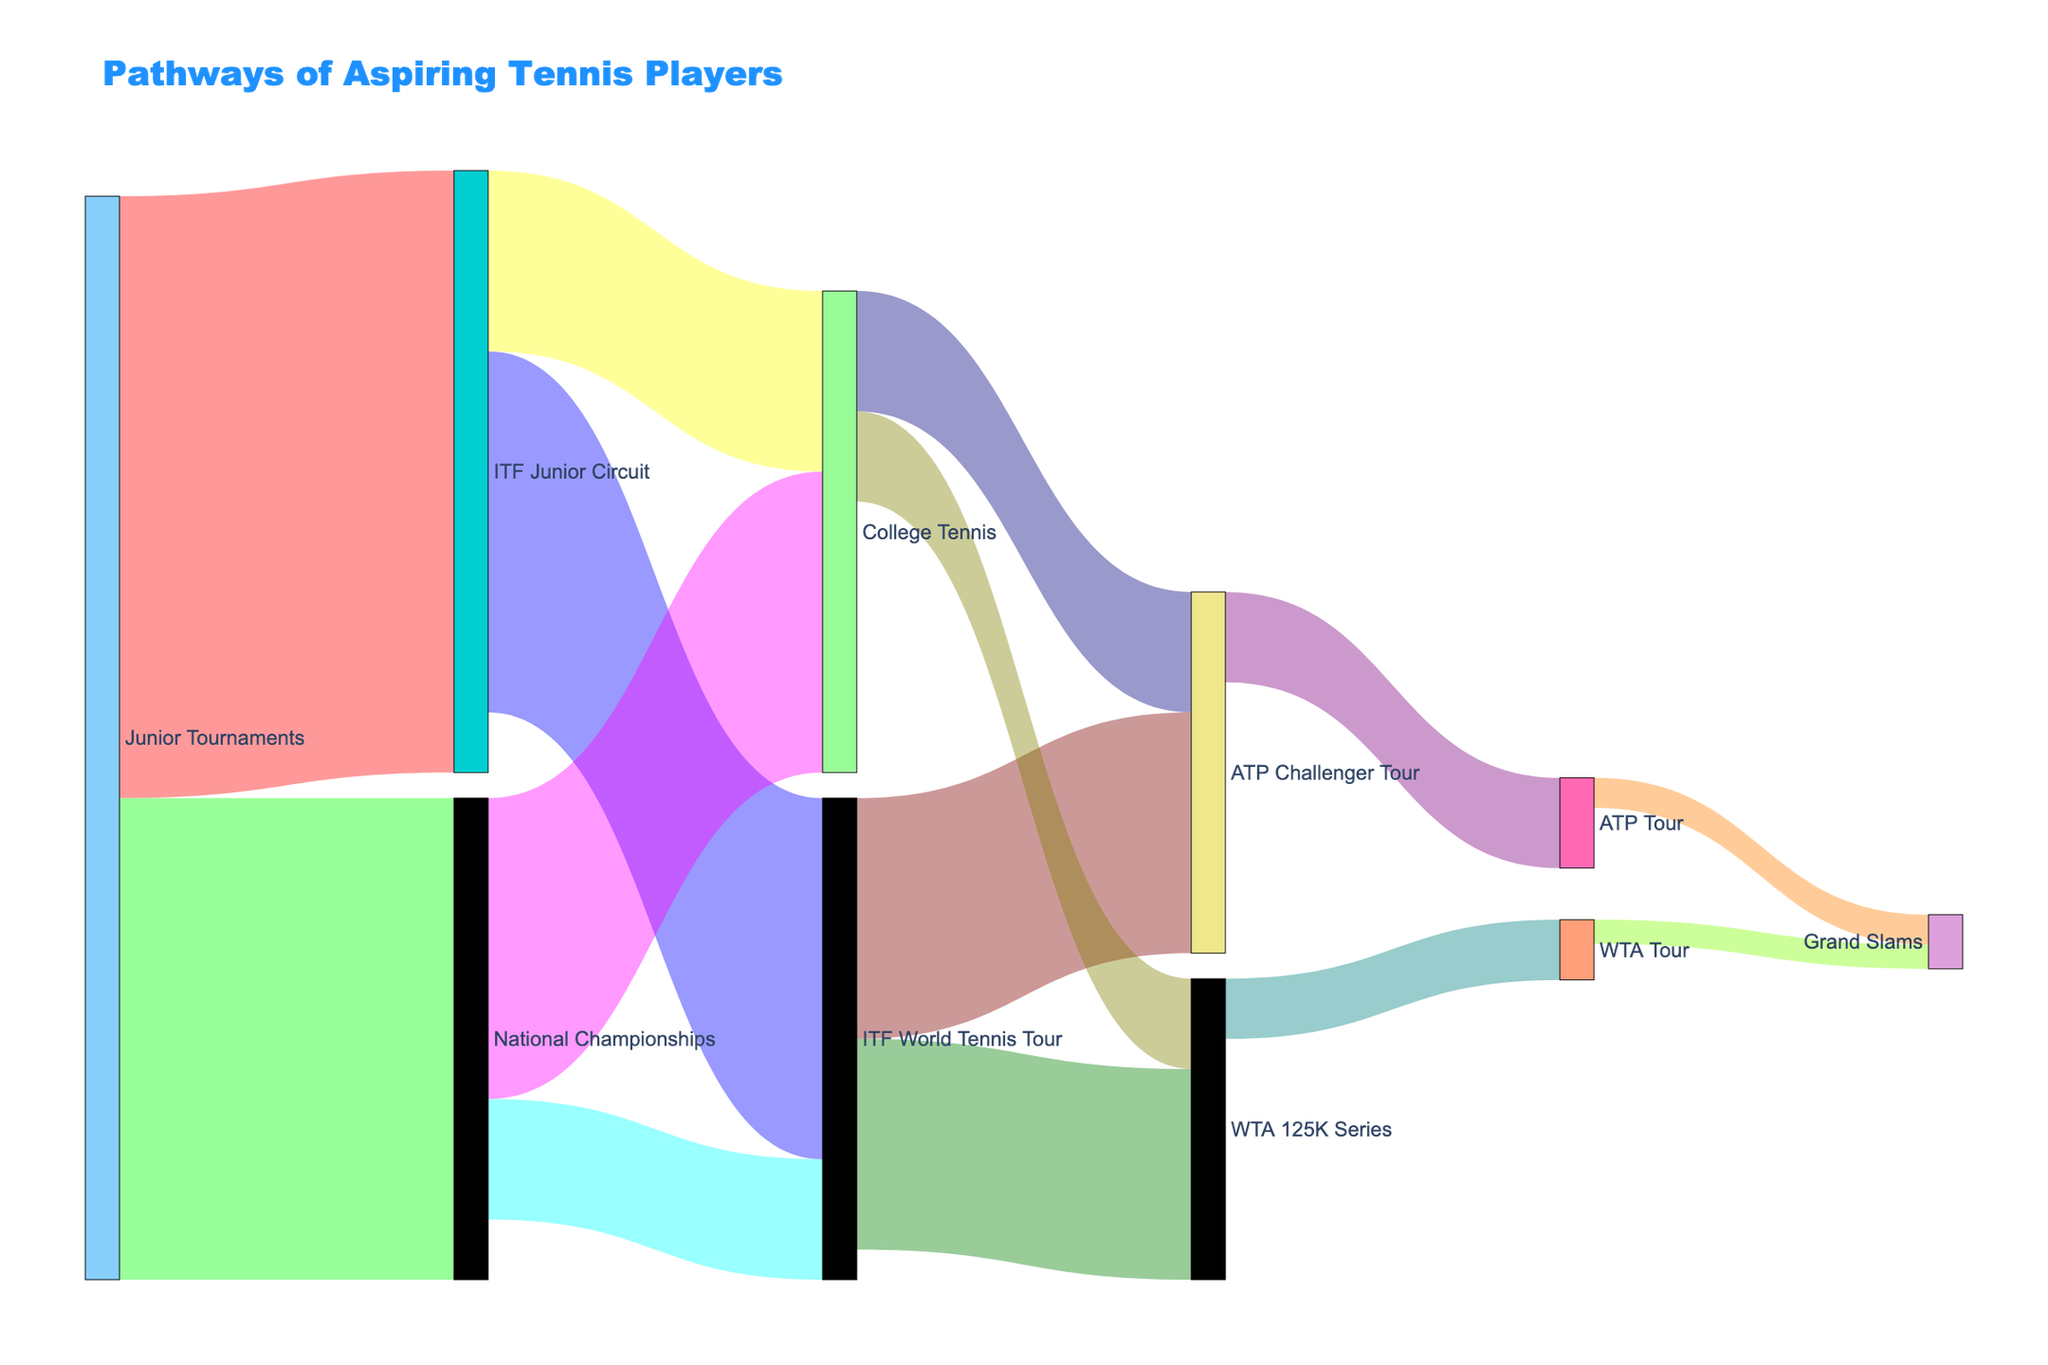What's the title of the figure? The title is usually displayed prominently at the top of the figure. In this case, it would be the text that describes the purpose of the diagram.
Answer: Pathways of Aspiring Tennis Players How many pathways lead from Junior Tournaments? Look at the starting point "Junior Tournaments" and count the number of connections (arrows) moving away from it to other nodes. There are arrows going to "ITF Junior Circuit" and "National Championships."
Answer: 2 Which pathway has the highest number of aspiring tennis players moving from National Championships? Identify the node "National Championships" and look at the values of the arrows going from this node to "College Tennis" and the "ITF World Tennis Tour." Compare the values.
Answer: College Tennis (500) What is the total number of players that move from ITF Junior Circuit to other tours? Look at the node "ITF Junior Circuit" and sum up the values of the arrows going to "ITF World Tennis Tour" and "College Tennis." Values are 600 and 300 respectively. Add them up: 600 + 300.
Answer: 900 From those who were in College Tennis, how many reach the ATP Tour and WTA Tour combined? Look at the node "College Tennis" and check the values of the arrows going to both the "ATP Challenger Tour" and "WTA 125K Series." Add those values up: 200 + 150.
Answer: 350 How many players reach the Grand Slams from the ATP Tour? Identify the connection between "ATP Tour" and "Grand Slams". You'll see a single arrow with the value corresponding to how many players make this transition.
Answer: 50 Which tour has a higher number of players moving from the ATP Challenger Tour, the ATP Tour or WTA Tour? Identify the two arrows leaving "ATP Challenger Tour" and compare their values. The arrows point to "ATP Tour" and "WTA Tour."
Answer: ATP Tour (150) How many players transition from ITF World Tennis Tour to the ATP Challenger Tour and WTA 125K Series combined? Look at the node "ITF World Tennis Tour" and sum up the values of the arrows leading to "ATP Challenger Tour" and "WTA 125K Series." Values are 400 and 350 respectively. Add them up: 400 + 350.
Answer: 750 What's the total number of players who end up in the Grand Slams? Identify the arrows leading to "Grand Slams" from both "ATP Tour" and "WTA Tour." Add these values. Values are 50 and 40 respectively. Add them up: 50 + 40.
Answer: 90 